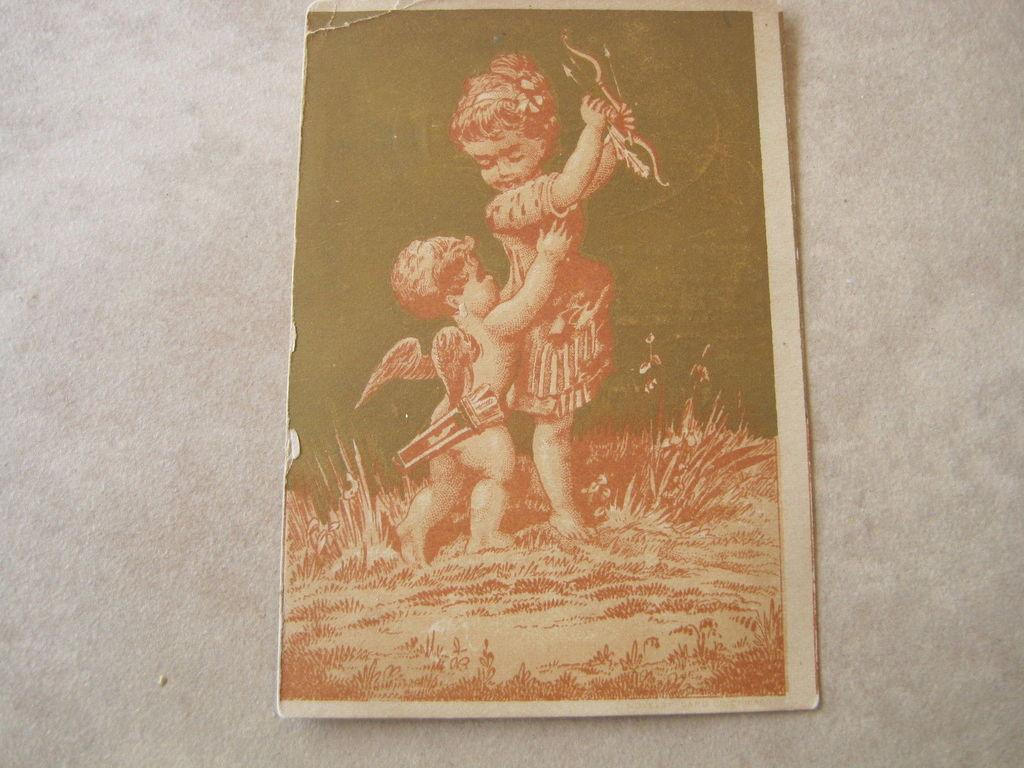What is attached to the wall in the image? There is a frame attached to the wall in the image. What can be seen inside the frame? The frame contains two children. What are the children holding in the image? The children are holding objects. What type of surface is visible in the image? There is grass on the surface in the image. Can you describe the appearance of one of the children in the frame? There is a small boy with two wings in the image. What type of flesh can be seen on the children's toes in the image? There is no visible flesh on the children's toes in the image, as they are wearing shoes. What hope does the small boy with wings have in the image? The image does not provide any information about the boy's hopes or aspirations. 